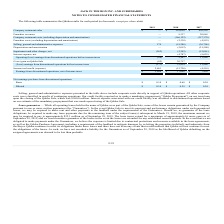According to Jack In The Box's financial document, How much was the Qdoba Prepayment? According to the financial document, $260.0 million. The relevant text states: "loan upon the closing of the Qdoba Sale, which was $260.0 million. Interest expense associated with our credit facility was allocated to discontinued operations base..." Also, What is the company restaurant sales in 2018? According to the financial document, $192,620 (in thousands). The relevant text states: "Company restaurant sales $ — $ 192,620 $ 436,558..." Also, Where was interest expense associated with our credit facility allocated to? Discontinued operations. The document states: "Operating (loss) earnings from discontinued operations before income taxes (88) 2,107 11,968..." Also, can you calculate: What is the difference in company restaurant sales between 2017 and 2018? Based on the calculation: $436,558-$192,620, the result is 243938 (in thousands). This is based on the information: "Company restaurant sales $ — $ 192,620 $ 436,558 Company restaurant sales $ — $ 192,620 $ 436,558..." The key data points involved are: 192,620, 436,558. Also, can you calculate: What is the average basic net earnings per share from discontinued operations from 2017-2019? To answer this question, I need to perform calculations using the financial data. The calculation is: (0.10+0.60+0.24)/3, which equals 0.31. This is based on the information: "Basic $ 0.10 $ 0.60 $ 0.24 Basic $ 0.10 $ 0.60 $ 0.24 Basic $ 0.10 $ 0.60 $ 0.24..." The key data points involved are: 0.10, 0.24, 0.60. Also, can you calculate: What is the difference in franchise revenues between 2017 and 2018? Based on the calculation: 20,065-9,337, the result is 10728 (in thousands). This is based on the information: "Franchise revenues — 9,337 20,065 Franchise revenues — 9,337 20,065..." The key data points involved are: 20,065, 9,337. 